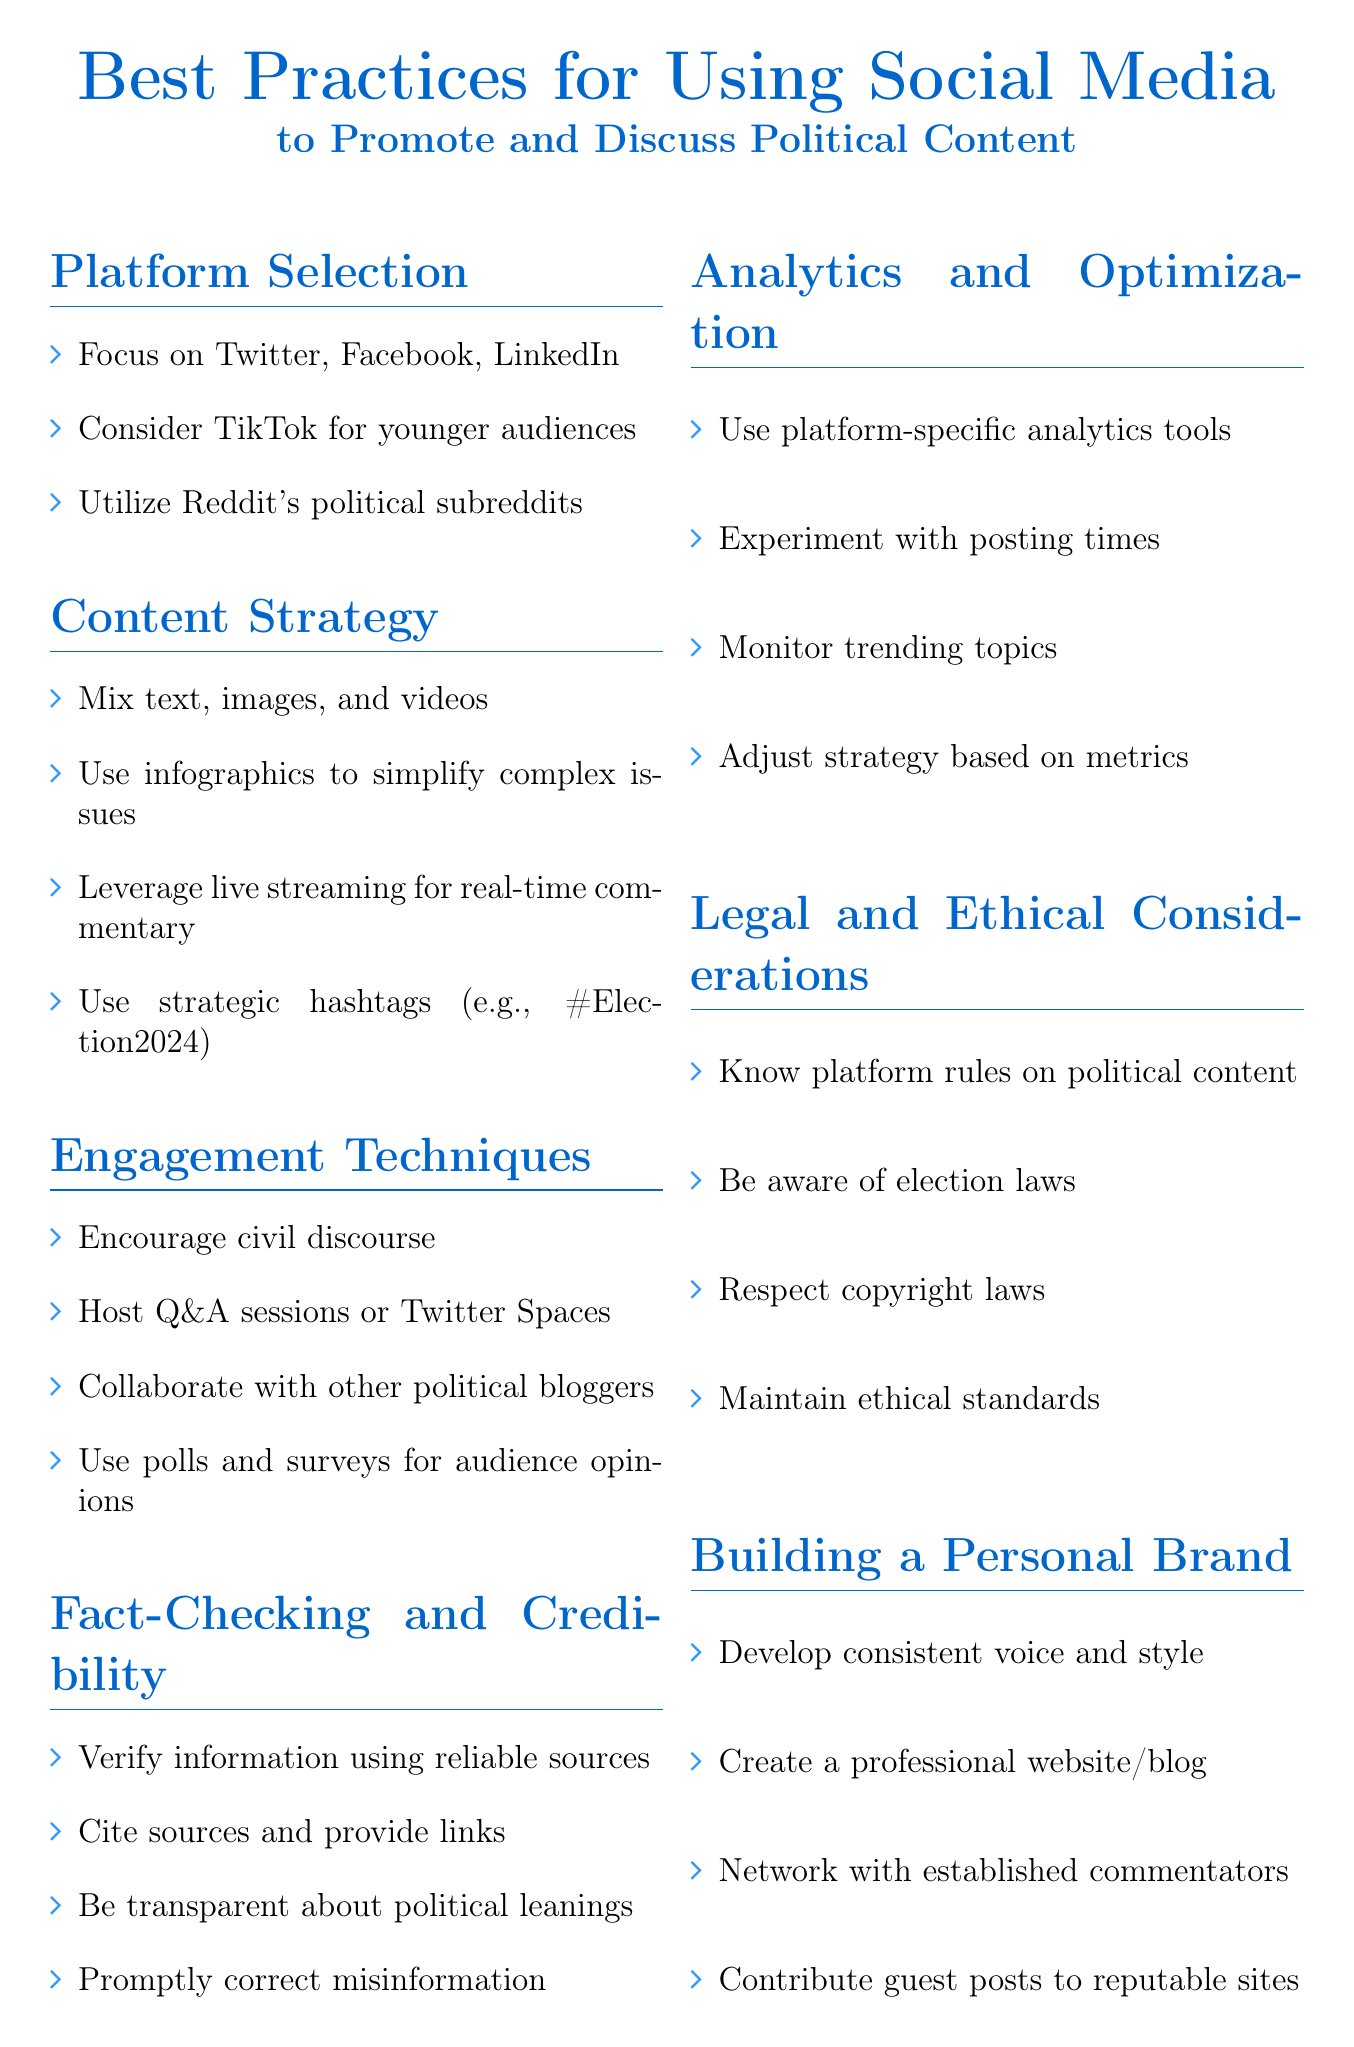What are the main platforms recommended for political content? The document lists Twitter, Facebook, and LinkedIn as the main platforms for political content.
Answer: Twitter, Facebook, LinkedIn What should be included in a content strategy? A content strategy should include a mix of text, images, and videos, as mentioned in the document.
Answer: Text, images, videos How can engagement be encouraged on social media? Engagement can be encouraged by moderating comments and responding to followers, as stated in the document.
Answer: Moderating comments, responding What is a crucial aspect of fact-checking? A crucial aspect of fact-checking is to verify information using reliable sources.
Answer: Verify information Which analytics tools should be used? The document suggests using platform-specific analytics tools like Twitter Analytics and Facebook Insights.
Answer: Twitter Analytics, Facebook Insights What is one legal consideration mentioned? One of the legal considerations is to be aware of election laws regarding online political advertising.
Answer: Election laws What type of posts can help in building a personal brand? Contributing guest posts to reputable political blogs or news sites can help in building a personal brand.
Answer: Guest posts How does the document suggest adjusting content strategy? The document suggests adjusting content strategy based on performance metrics and audience feedback.
Answer: Performance metrics, audience feedback What is the conclusion of the memo? The conclusion states that implementing these best practices will help you effectively use social media for political content promotion.
Answer: Implementing best practices 